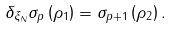<formula> <loc_0><loc_0><loc_500><loc_500>\delta _ { \xi _ { N } } \sigma _ { p } \left ( \rho _ { 1 } \right ) = \sigma _ { p + 1 } \left ( \rho _ { 2 } \right ) .</formula> 